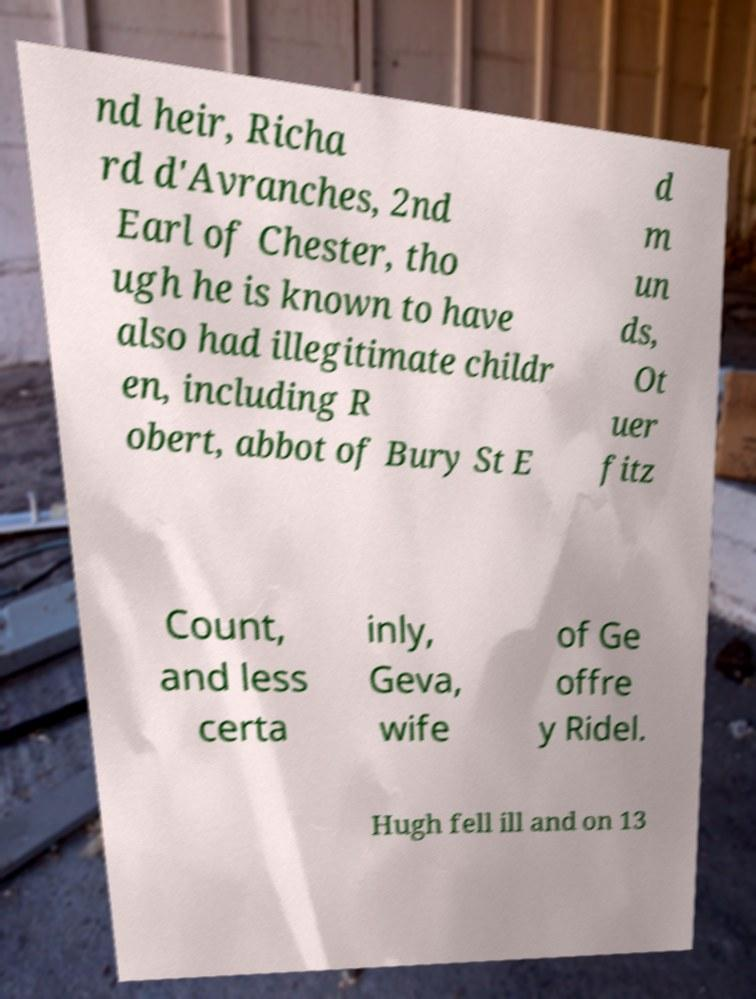Can you read and provide the text displayed in the image?This photo seems to have some interesting text. Can you extract and type it out for me? nd heir, Richa rd d'Avranches, 2nd Earl of Chester, tho ugh he is known to have also had illegitimate childr en, including R obert, abbot of Bury St E d m un ds, Ot uer fitz Count, and less certa inly, Geva, wife of Ge offre y Ridel. Hugh fell ill and on 13 